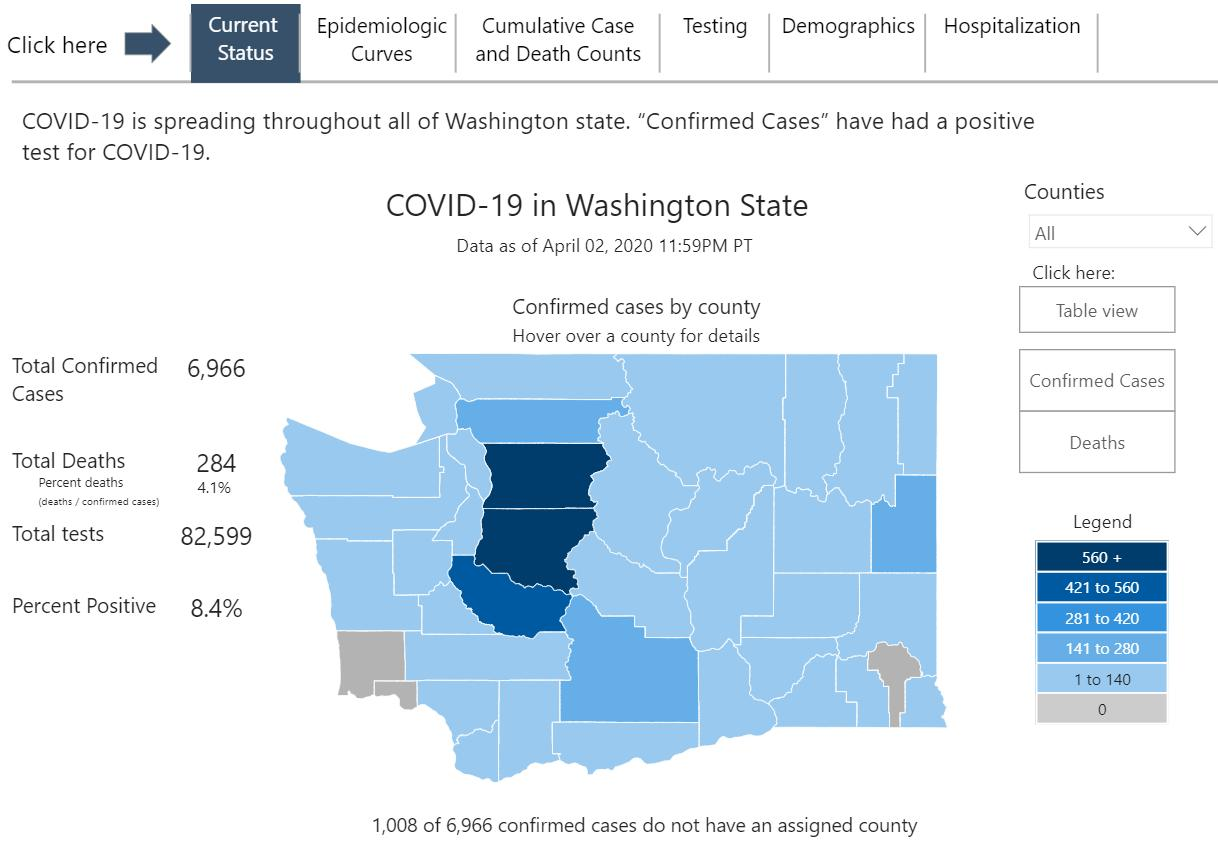Indicate a few pertinent items in this graphic. The case count in Snohomish is 560 and counting. The confirmed case count in Spokane is between 141 and 280. There are currently no confirmed cases of the disease in the Pacific region. The case count for Pierce County, Washington, has increased from 421 to 560 confirmed cases. The count in most of the counties is within the range of 1 to 140. 